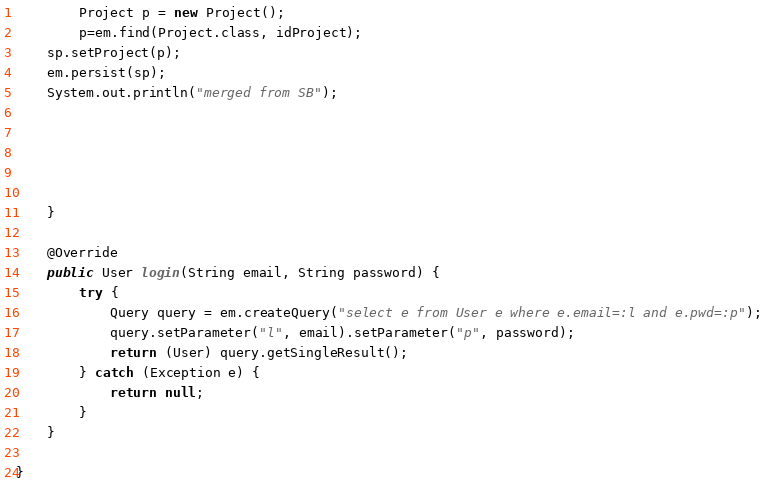Convert code to text. <code><loc_0><loc_0><loc_500><loc_500><_Java_>		Project p = new Project();
		p=em.find(Project.class, idProject);
	sp.setProject(p);
	em.persist(sp);
	System.out.println("merged from SB");
		
		
		
		
		
	}

	@Override
	public User login(String email, String password) {
		try {
			Query query = em.createQuery("select e from User e where e.email=:l and e.pwd=:p");
			query.setParameter("l", email).setParameter("p", password);
			return (User) query.getSingleResult();
		} catch (Exception e) {
			return null;
		}
	}

}
</code> 